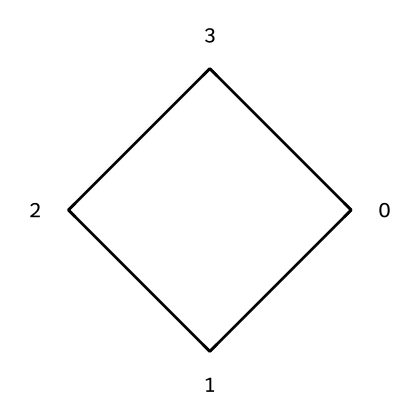What is the molecular formula of cyclobutane? The skeletal formula shows four carbon atoms in a ring with two hydrogen atoms attached to each carbon. This gives the molecular formula C4H8.
Answer: C4H8 How many carbon atoms are present in cyclobutane? Counting the carbon atoms in the skeletal formula, there are four carbon atoms arranged in a ring.
Answer: four What type of compound is cyclobutane? Cyclobutane is classified as a cycloalkane due to its cyclic structure and saturated nature, meaning all carbon-to-carbon bonds are single bonds.
Answer: cycloalkane How many hydrogen atoms are bonded to each carbon in cyclobutane? In cyclobutane, each of the four carbon atoms has two hydrogen atoms bonded to it, consistent with its molecular formula.
Answer: two What is the shape of the cyclobutane molecule? The cyclobutane molecule adopts a puckered conformation to reduce angle strain, leading to a non-planar shape.
Answer: puckered What type of reaction does cyclobutane commonly undergo? Cyclobutane can undergo various reactions typical for alkanes, such as hydrogenation, where it can react with hydrogen.
Answer: hydrogenation Why is cyclobutane less stable than larger cycloalkanes? The bond angles in cyclobutane are smaller than the ideal tetrahedral angle (109.5 degrees), creating angle strain compared to larger cycloalkanes that have more favorable angles.
Answer: angle strain 